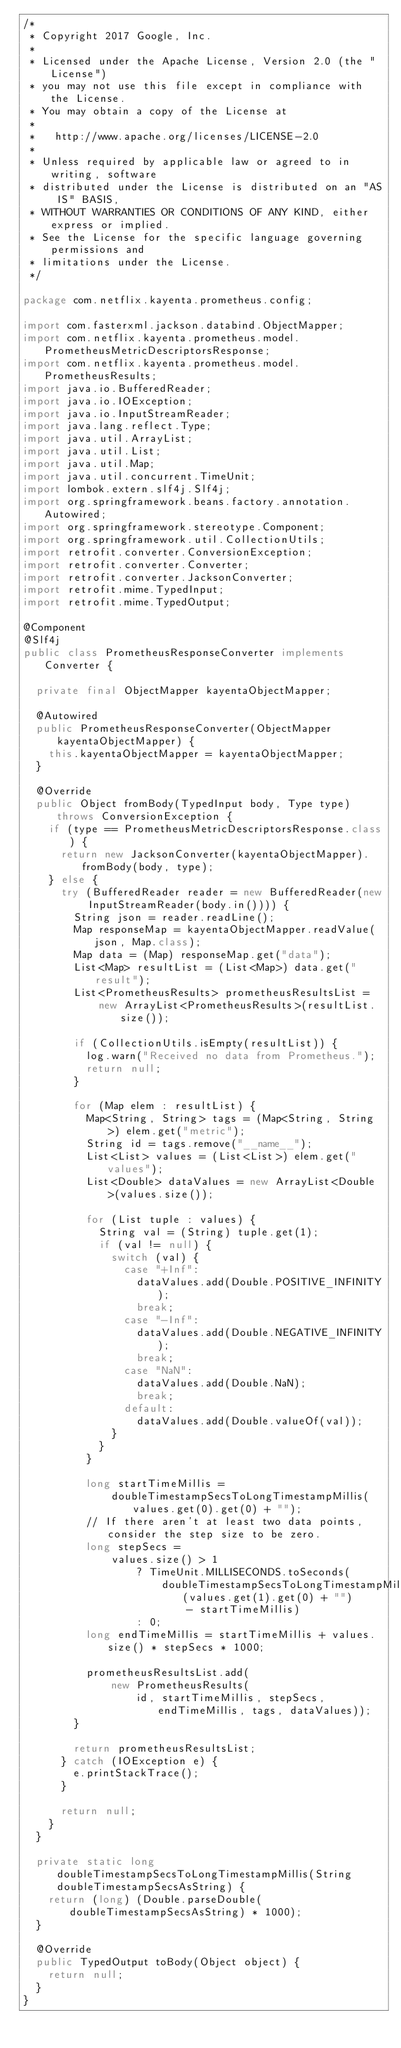Convert code to text. <code><loc_0><loc_0><loc_500><loc_500><_Java_>/*
 * Copyright 2017 Google, Inc.
 *
 * Licensed under the Apache License, Version 2.0 (the "License")
 * you may not use this file except in compliance with the License.
 * You may obtain a copy of the License at
 *
 *   http://www.apache.org/licenses/LICENSE-2.0
 *
 * Unless required by applicable law or agreed to in writing, software
 * distributed under the License is distributed on an "AS IS" BASIS,
 * WITHOUT WARRANTIES OR CONDITIONS OF ANY KIND, either express or implied.
 * See the License for the specific language governing permissions and
 * limitations under the License.
 */

package com.netflix.kayenta.prometheus.config;

import com.fasterxml.jackson.databind.ObjectMapper;
import com.netflix.kayenta.prometheus.model.PrometheusMetricDescriptorsResponse;
import com.netflix.kayenta.prometheus.model.PrometheusResults;
import java.io.BufferedReader;
import java.io.IOException;
import java.io.InputStreamReader;
import java.lang.reflect.Type;
import java.util.ArrayList;
import java.util.List;
import java.util.Map;
import java.util.concurrent.TimeUnit;
import lombok.extern.slf4j.Slf4j;
import org.springframework.beans.factory.annotation.Autowired;
import org.springframework.stereotype.Component;
import org.springframework.util.CollectionUtils;
import retrofit.converter.ConversionException;
import retrofit.converter.Converter;
import retrofit.converter.JacksonConverter;
import retrofit.mime.TypedInput;
import retrofit.mime.TypedOutput;

@Component
@Slf4j
public class PrometheusResponseConverter implements Converter {

  private final ObjectMapper kayentaObjectMapper;

  @Autowired
  public PrometheusResponseConverter(ObjectMapper kayentaObjectMapper) {
    this.kayentaObjectMapper = kayentaObjectMapper;
  }

  @Override
  public Object fromBody(TypedInput body, Type type) throws ConversionException {
    if (type == PrometheusMetricDescriptorsResponse.class) {
      return new JacksonConverter(kayentaObjectMapper).fromBody(body, type);
    } else {
      try (BufferedReader reader = new BufferedReader(new InputStreamReader(body.in()))) {
        String json = reader.readLine();
        Map responseMap = kayentaObjectMapper.readValue(json, Map.class);
        Map data = (Map) responseMap.get("data");
        List<Map> resultList = (List<Map>) data.get("result");
        List<PrometheusResults> prometheusResultsList =
            new ArrayList<PrometheusResults>(resultList.size());

        if (CollectionUtils.isEmpty(resultList)) {
          log.warn("Received no data from Prometheus.");
          return null;
        }

        for (Map elem : resultList) {
          Map<String, String> tags = (Map<String, String>) elem.get("metric");
          String id = tags.remove("__name__");
          List<List> values = (List<List>) elem.get("values");
          List<Double> dataValues = new ArrayList<Double>(values.size());

          for (List tuple : values) {
            String val = (String) tuple.get(1);
            if (val != null) {
              switch (val) {
                case "+Inf":
                  dataValues.add(Double.POSITIVE_INFINITY);
                  break;
                case "-Inf":
                  dataValues.add(Double.NEGATIVE_INFINITY);
                  break;
                case "NaN":
                  dataValues.add(Double.NaN);
                  break;
                default:
                  dataValues.add(Double.valueOf(val));
              }
            }
          }

          long startTimeMillis =
              doubleTimestampSecsToLongTimestampMillis(values.get(0).get(0) + "");
          // If there aren't at least two data points, consider the step size to be zero.
          long stepSecs =
              values.size() > 1
                  ? TimeUnit.MILLISECONDS.toSeconds(
                      doubleTimestampSecsToLongTimestampMillis(values.get(1).get(0) + "")
                          - startTimeMillis)
                  : 0;
          long endTimeMillis = startTimeMillis + values.size() * stepSecs * 1000;

          prometheusResultsList.add(
              new PrometheusResults(
                  id, startTimeMillis, stepSecs, endTimeMillis, tags, dataValues));
        }

        return prometheusResultsList;
      } catch (IOException e) {
        e.printStackTrace();
      }

      return null;
    }
  }

  private static long doubleTimestampSecsToLongTimestampMillis(String doubleTimestampSecsAsString) {
    return (long) (Double.parseDouble(doubleTimestampSecsAsString) * 1000);
  }

  @Override
  public TypedOutput toBody(Object object) {
    return null;
  }
}
</code> 